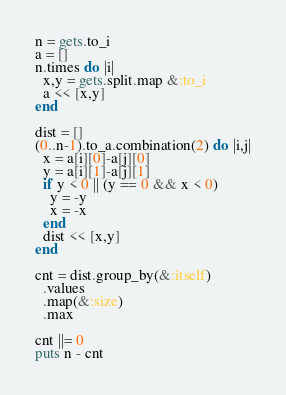<code> <loc_0><loc_0><loc_500><loc_500><_Ruby_>n = gets.to_i
a = []
n.times do |i|
  x,y = gets.split.map &:to_i
  a << [x,y]
end

dist = []
(0..n-1).to_a.combination(2) do |i,j|
  x = a[i][0]-a[j][0]
  y = a[i][1]-a[j][1]
  if y < 0 || (y == 0 && x < 0)
    y = -y
    x = -x
  end
  dist << [x,y]
end

cnt = dist.group_by(&:itself)
  .values
  .map(&:size)
  .max

cnt ||= 0
puts n - cnt</code> 